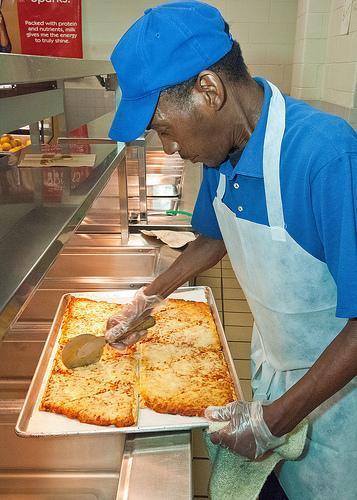How many people are shown?
Give a very brief answer. 1. 